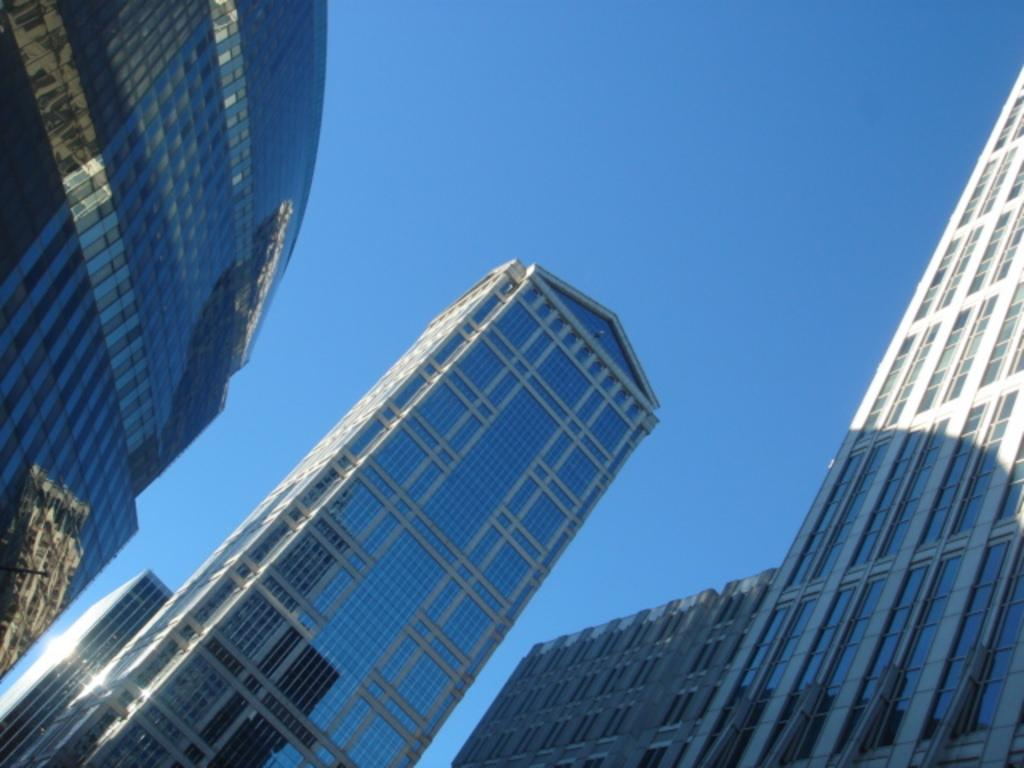What type of structures can be seen in the image? There are buildings in the image. What is a specific feature of the buildings' windows? The windows of the buildings are blue in color. What can be seen in the background of the image? The sky is visible in the background of the image. What is the distribution of the society in the image? There is no information about a society or its distribution in the image. The image only shows buildings with blue windows and a visible sky in the background. 